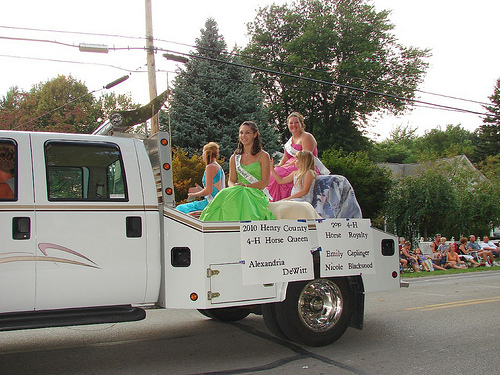<image>
Is there a dress in the truck? Yes. The dress is contained within or inside the truck, showing a containment relationship. Is there a girl above the tire? Yes. The girl is positioned above the tire in the vertical space, higher up in the scene. 